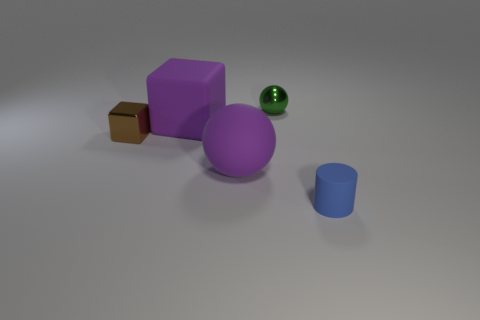Does the large sphere have the same color as the big thing behind the brown object?
Offer a very short reply. Yes. What is the shape of the big thing that is the same color as the large cube?
Your answer should be very brief. Sphere. How many things are rubber things that are left of the tiny green metallic object or tiny things behind the blue matte object?
Offer a terse response. 4. How many tiny blue things are the same shape as the small green metallic thing?
Keep it short and to the point. 0. There is a metal block that is the same size as the cylinder; what color is it?
Offer a very short reply. Brown. There is a big thing that is in front of the block that is to the right of the shiny thing left of the purple rubber ball; what is its color?
Provide a short and direct response. Purple. There is a purple matte sphere; is its size the same as the purple matte thing behind the rubber ball?
Give a very brief answer. Yes. How many objects are either blue things or tiny brown matte things?
Your response must be concise. 1. Is there a cylinder that has the same material as the large purple block?
Your answer should be very brief. Yes. What size is the sphere that is the same color as the matte cube?
Offer a terse response. Large. 